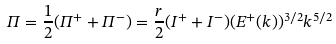Convert formula to latex. <formula><loc_0><loc_0><loc_500><loc_500>\Pi = \frac { 1 } { 2 } ( \Pi ^ { + } + \Pi ^ { - } ) = \frac { r } { 2 } ( I ^ { + } + I ^ { - } ) ( E ^ { + } ( k ) ) ^ { 3 / 2 } k ^ { 5 / 2 }</formula> 